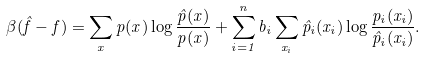Convert formula to latex. <formula><loc_0><loc_0><loc_500><loc_500>\beta ( \hat { f } - f ) = \sum _ { x } p ( x ) \log \frac { \hat { p } ( x ) } { p ( x ) } + \sum _ { i = 1 } ^ { n } b _ { i } \sum _ { x _ { i } } \hat { p } _ { i } ( x _ { i } ) \log \frac { p _ { i } ( x _ { i } ) } { \hat { p } _ { i } ( x _ { i } ) } .</formula> 